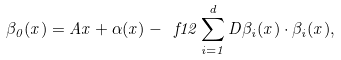<formula> <loc_0><loc_0><loc_500><loc_500>\beta _ { 0 } ( x ) = A x + \alpha ( x ) - \ f { 1 } { 2 } \sum _ { i = 1 } ^ { d } D \beta _ { i } ( x ) \cdot \beta _ { i } ( x ) ,</formula> 